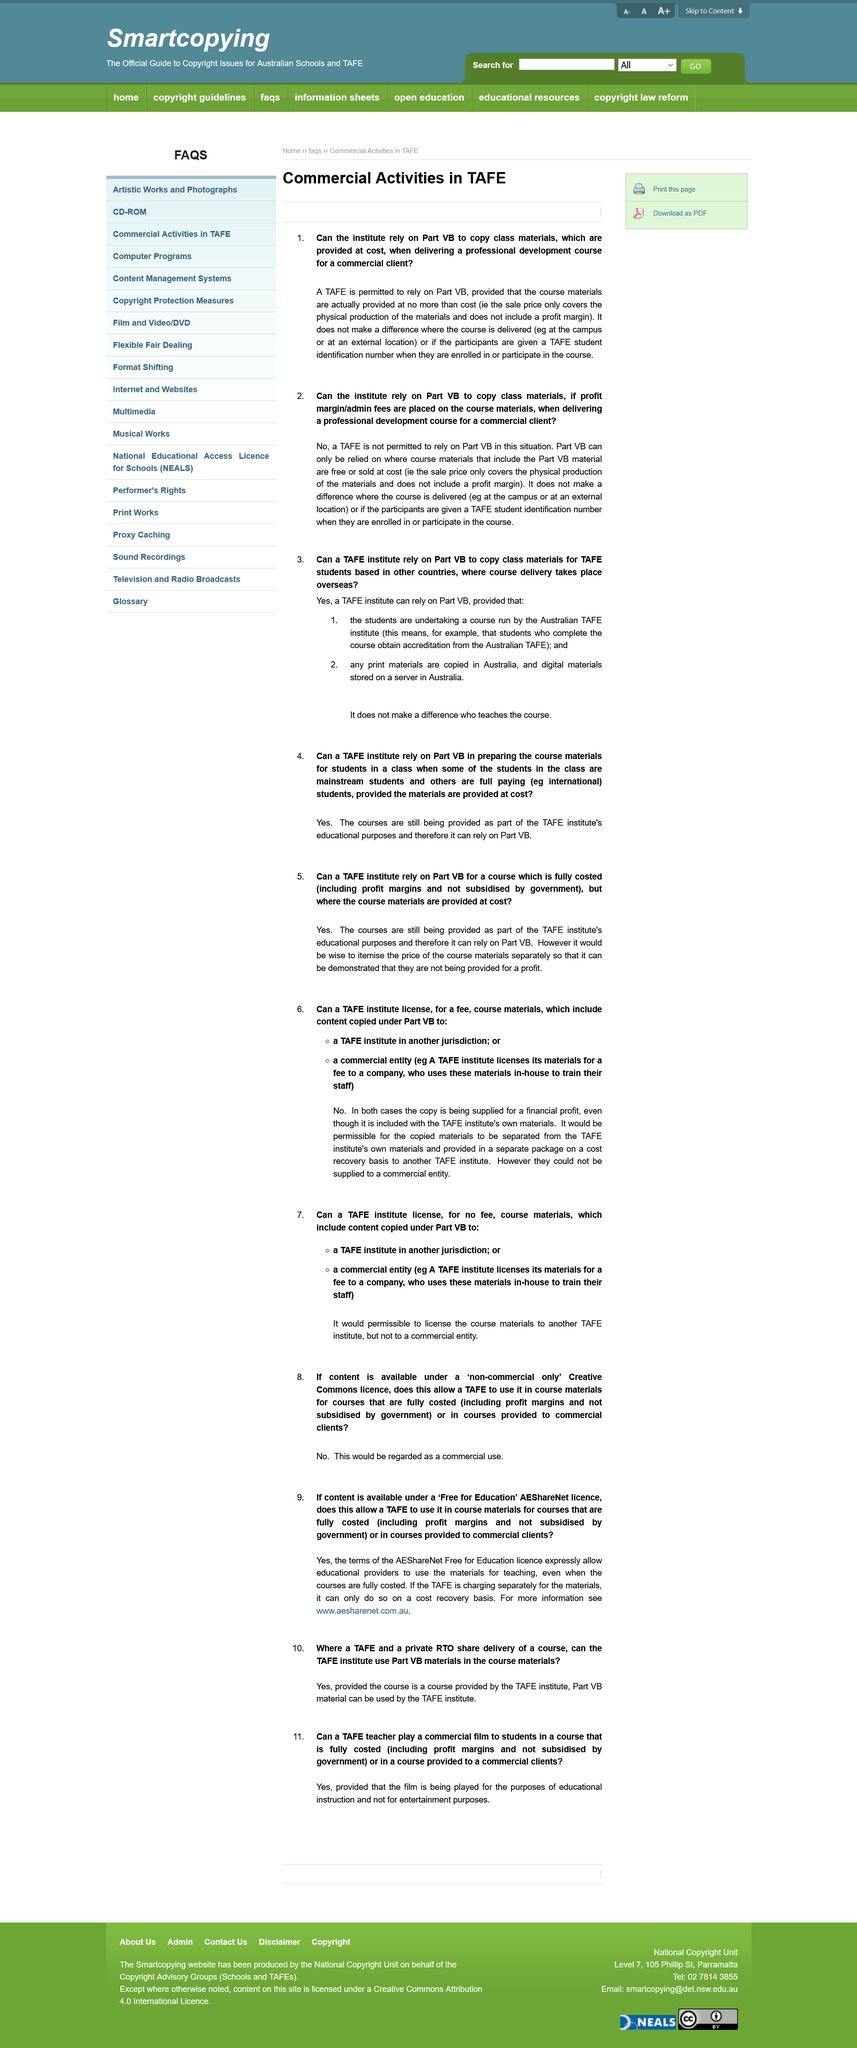Mention a couple of crucial points in this snapshot. The phrase 'provided at cost' means that the sale price of the class materials only covers the physical production of the materials and does not include a profit margin, as it is intended to only cover the cost of the materials and not generate a profit. It does not make a difference where the course is delivered if a TAFE is permitted. Commercial entities are prohibited from obtaining a license to copy course materials from a TAFE Institute for financial gain. The commercial entity is using the TAFE Institute's own materials for its own use, such as training its own staff in-house, which is an example of the commercial entity's TAFE Institute materials for its own use. The institute is permitted to engage in commercial activities, including providing professional development courses for a commercial client. 